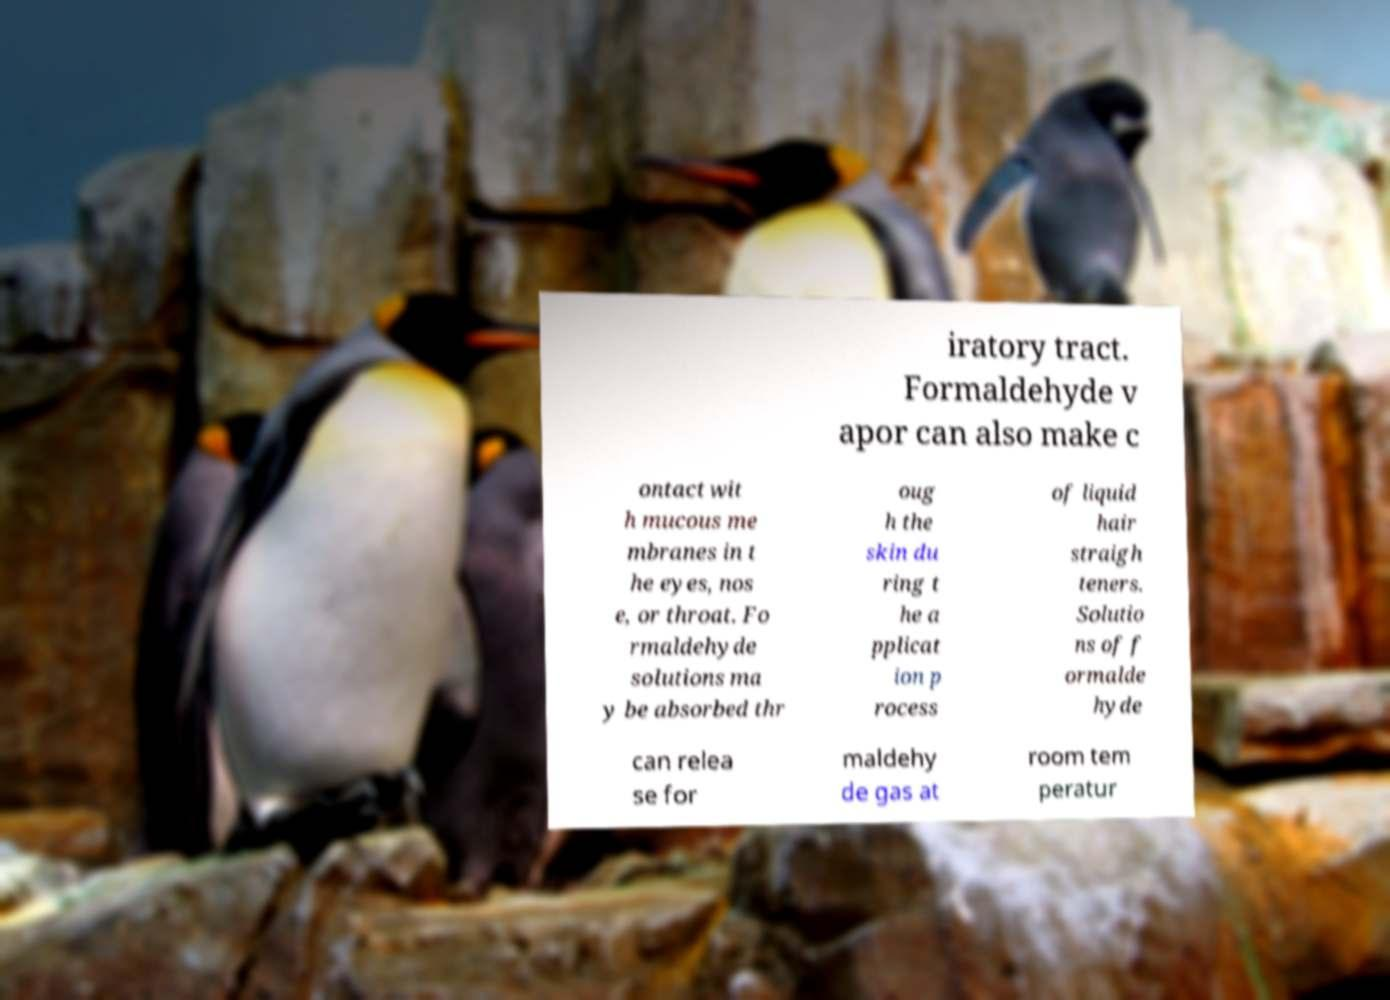I need the written content from this picture converted into text. Can you do that? iratory tract. Formaldehyde v apor can also make c ontact wit h mucous me mbranes in t he eyes, nos e, or throat. Fo rmaldehyde solutions ma y be absorbed thr oug h the skin du ring t he a pplicat ion p rocess of liquid hair straigh teners. Solutio ns of f ormalde hyde can relea se for maldehy de gas at room tem peratur 